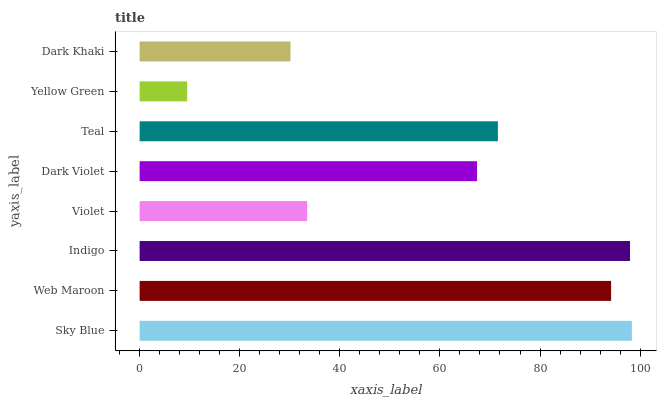Is Yellow Green the minimum?
Answer yes or no. Yes. Is Sky Blue the maximum?
Answer yes or no. Yes. Is Web Maroon the minimum?
Answer yes or no. No. Is Web Maroon the maximum?
Answer yes or no. No. Is Sky Blue greater than Web Maroon?
Answer yes or no. Yes. Is Web Maroon less than Sky Blue?
Answer yes or no. Yes. Is Web Maroon greater than Sky Blue?
Answer yes or no. No. Is Sky Blue less than Web Maroon?
Answer yes or no. No. Is Teal the high median?
Answer yes or no. Yes. Is Dark Violet the low median?
Answer yes or no. Yes. Is Dark Khaki the high median?
Answer yes or no. No. Is Sky Blue the low median?
Answer yes or no. No. 